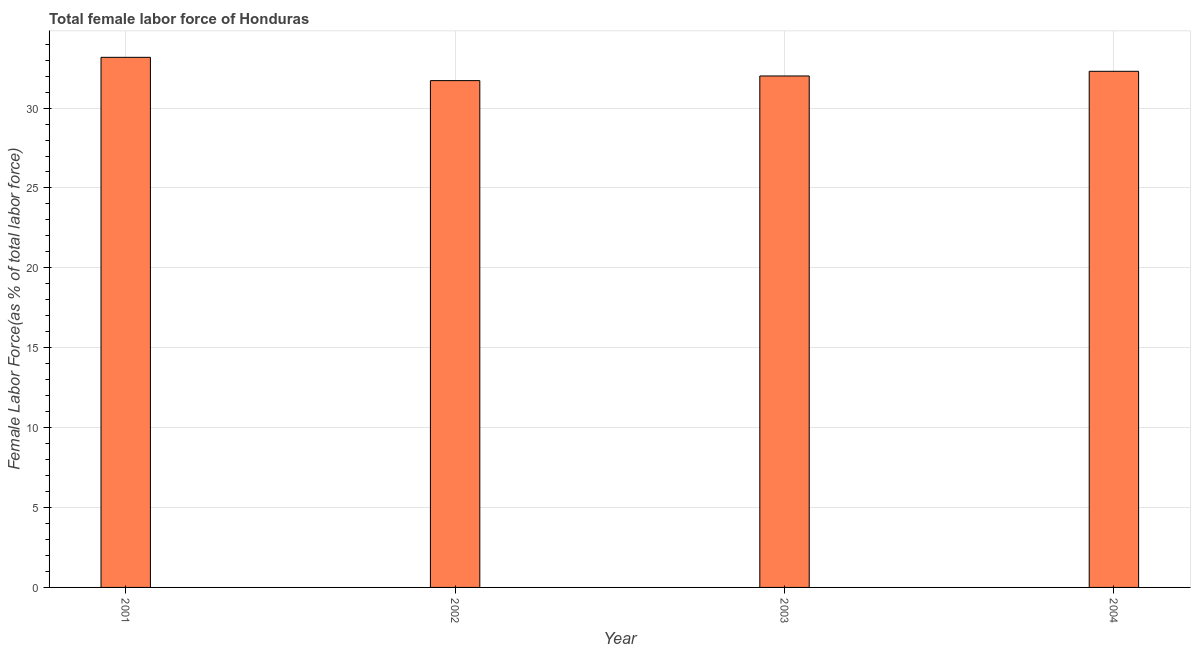Does the graph contain any zero values?
Your answer should be compact. No. Does the graph contain grids?
Provide a short and direct response. Yes. What is the title of the graph?
Provide a succinct answer. Total female labor force of Honduras. What is the label or title of the Y-axis?
Give a very brief answer. Female Labor Force(as % of total labor force). What is the total female labor force in 2004?
Your answer should be compact. 32.3. Across all years, what is the maximum total female labor force?
Keep it short and to the point. 33.18. Across all years, what is the minimum total female labor force?
Your response must be concise. 31.72. What is the sum of the total female labor force?
Give a very brief answer. 129.2. What is the difference between the total female labor force in 2001 and 2002?
Offer a very short reply. 1.46. What is the average total female labor force per year?
Your answer should be compact. 32.3. What is the median total female labor force?
Provide a short and direct response. 32.15. Do a majority of the years between 2002 and 2001 (inclusive) have total female labor force greater than 24 %?
Your answer should be very brief. No. Is the total female labor force in 2001 less than that in 2003?
Keep it short and to the point. No. Is the difference between the total female labor force in 2002 and 2004 greater than the difference between any two years?
Provide a succinct answer. No. What is the difference between the highest and the second highest total female labor force?
Ensure brevity in your answer.  0.87. What is the difference between the highest and the lowest total female labor force?
Make the answer very short. 1.46. In how many years, is the total female labor force greater than the average total female labor force taken over all years?
Your response must be concise. 2. How many years are there in the graph?
Make the answer very short. 4. What is the difference between two consecutive major ticks on the Y-axis?
Ensure brevity in your answer.  5. Are the values on the major ticks of Y-axis written in scientific E-notation?
Offer a terse response. No. What is the Female Labor Force(as % of total labor force) in 2001?
Ensure brevity in your answer.  33.18. What is the Female Labor Force(as % of total labor force) in 2002?
Your answer should be very brief. 31.72. What is the Female Labor Force(as % of total labor force) in 2003?
Offer a terse response. 32.01. What is the Female Labor Force(as % of total labor force) of 2004?
Offer a terse response. 32.3. What is the difference between the Female Labor Force(as % of total labor force) in 2001 and 2002?
Your response must be concise. 1.46. What is the difference between the Female Labor Force(as % of total labor force) in 2001 and 2003?
Make the answer very short. 1.17. What is the difference between the Female Labor Force(as % of total labor force) in 2001 and 2004?
Keep it short and to the point. 0.87. What is the difference between the Female Labor Force(as % of total labor force) in 2002 and 2003?
Give a very brief answer. -0.29. What is the difference between the Female Labor Force(as % of total labor force) in 2002 and 2004?
Give a very brief answer. -0.58. What is the difference between the Female Labor Force(as % of total labor force) in 2003 and 2004?
Provide a succinct answer. -0.29. What is the ratio of the Female Labor Force(as % of total labor force) in 2001 to that in 2002?
Your response must be concise. 1.05. What is the ratio of the Female Labor Force(as % of total labor force) in 2001 to that in 2003?
Offer a terse response. 1.04. What is the ratio of the Female Labor Force(as % of total labor force) in 2002 to that in 2003?
Provide a succinct answer. 0.99. What is the ratio of the Female Labor Force(as % of total labor force) in 2002 to that in 2004?
Ensure brevity in your answer.  0.98. What is the ratio of the Female Labor Force(as % of total labor force) in 2003 to that in 2004?
Your answer should be compact. 0.99. 